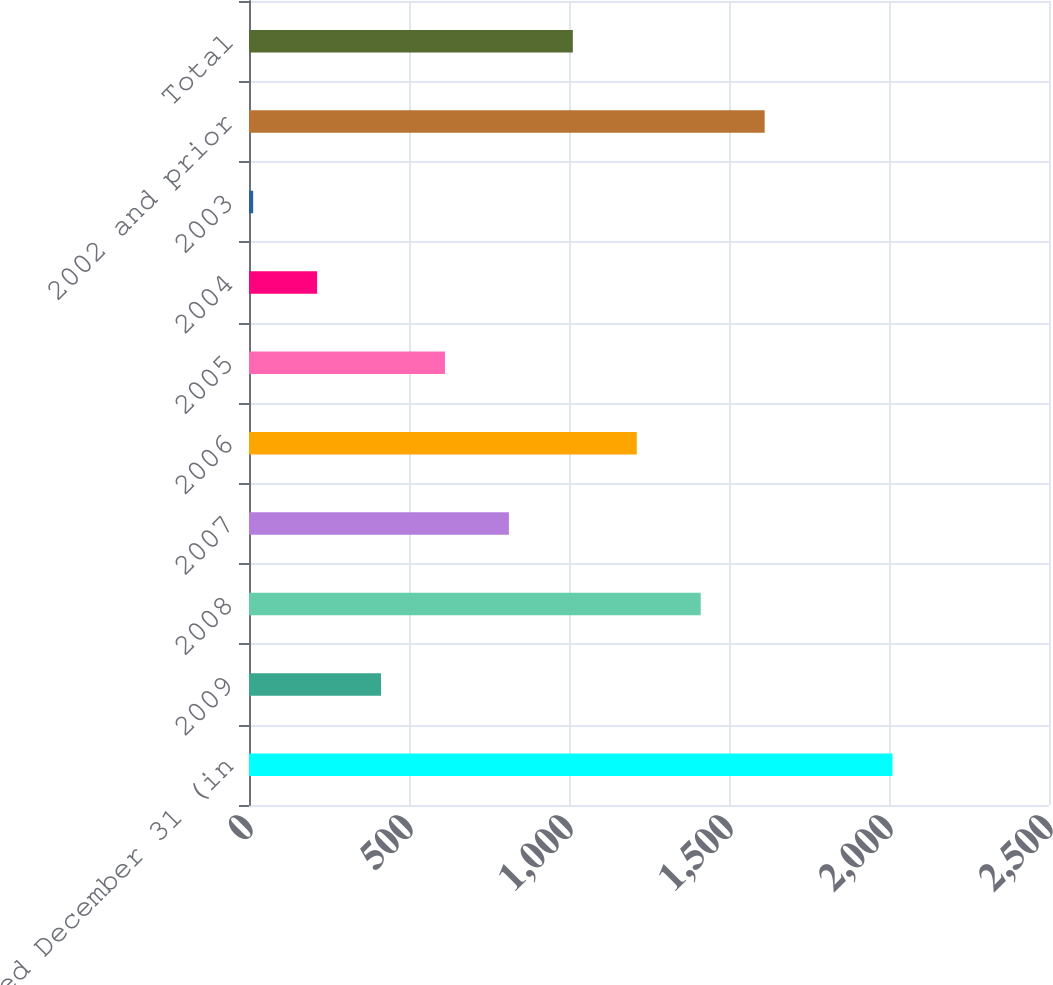Convert chart to OTSL. <chart><loc_0><loc_0><loc_500><loc_500><bar_chart><fcel>Years Ended December 31 (in<fcel>2009<fcel>2008<fcel>2007<fcel>2006<fcel>2005<fcel>2004<fcel>2003<fcel>2002 and prior<fcel>Total<nl><fcel>2011<fcel>412.6<fcel>1411.6<fcel>812.2<fcel>1211.8<fcel>612.4<fcel>212.8<fcel>13<fcel>1611.4<fcel>1012<nl></chart> 